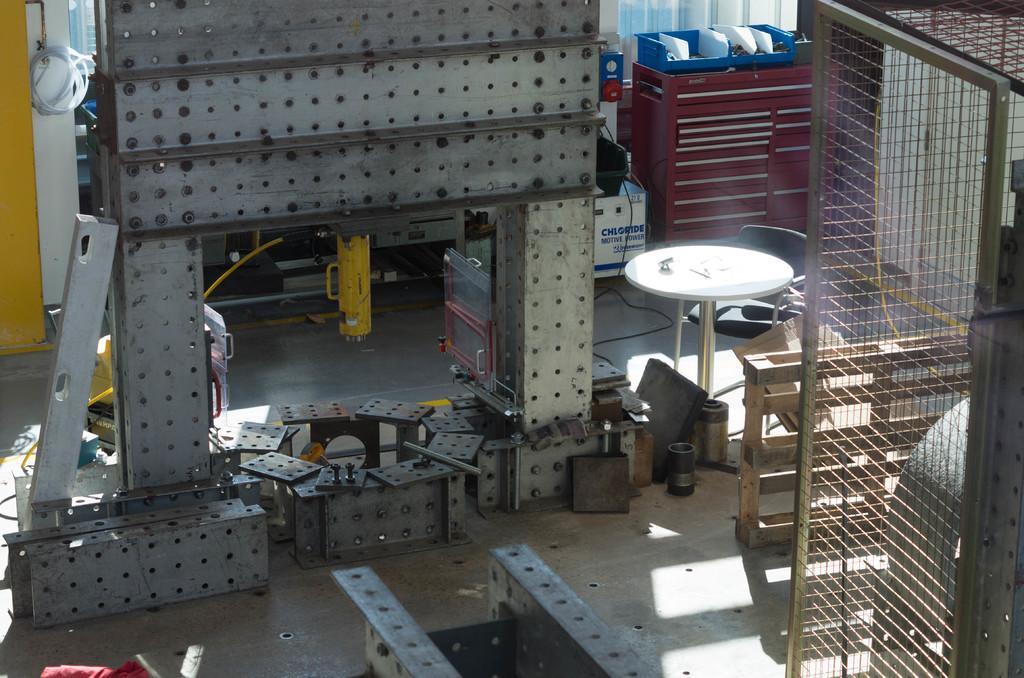Can you describe this image briefly? In this picture I can observe some metal plates with holes in the middle of the picture. On the right side there is a table and I can observe black color chair beside the table. There is a fence on the right side. In the background I can observe a red color desk. 